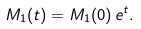Convert formula to latex. <formula><loc_0><loc_0><loc_500><loc_500>M _ { 1 } ( t ) = M _ { 1 } ( 0 ) \, e ^ { t } .</formula> 